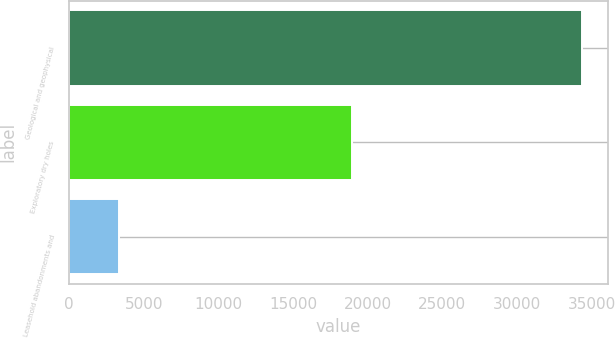<chart> <loc_0><loc_0><loc_500><loc_500><bar_chart><fcel>Geological and geophysical<fcel>Exploratory dry holes<fcel>Leasehold abandonments and<nl><fcel>34353<fcel>18981<fcel>3318<nl></chart> 